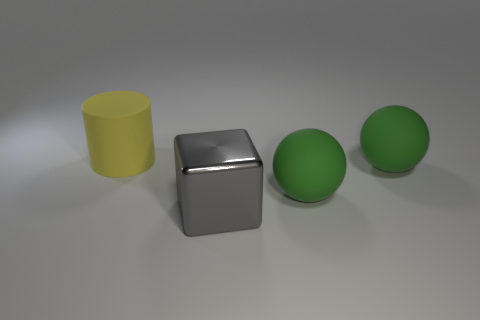What number of other things are there of the same size as the cylinder?
Offer a terse response. 3. How many objects are either small green objects or big rubber things that are in front of the large matte cylinder?
Offer a terse response. 2. What number of other objects are there of the same shape as the large gray thing?
Keep it short and to the point. 0. What number of metallic objects are gray objects or large cylinders?
Your answer should be very brief. 1. Is there a brown cylinder that has the same material as the gray block?
Offer a terse response. No. The big metallic cube is what color?
Offer a very short reply. Gray. There is a object that is left of the large gray thing; what is its size?
Your answer should be compact. Large. There is a rubber thing to the left of the gray object; are there any big gray objects that are on the left side of it?
Your answer should be compact. No. There is a matte cylinder that is the same size as the gray shiny object; what color is it?
Offer a terse response. Yellow. Is the number of things behind the gray metal block the same as the number of rubber things in front of the yellow rubber cylinder?
Offer a very short reply. No. 